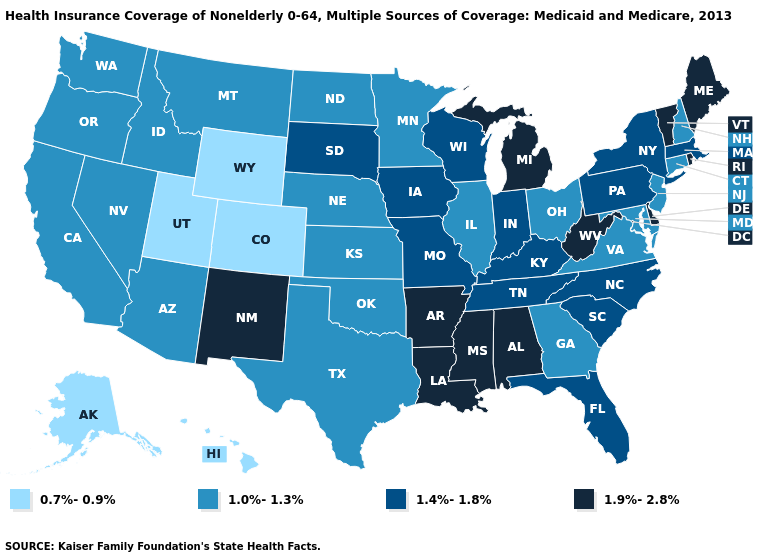Is the legend a continuous bar?
Quick response, please. No. Among the states that border New Hampshire , does Massachusetts have the highest value?
Short answer required. No. What is the lowest value in the Northeast?
Be succinct. 1.0%-1.3%. Name the states that have a value in the range 1.0%-1.3%?
Answer briefly. Arizona, California, Connecticut, Georgia, Idaho, Illinois, Kansas, Maryland, Minnesota, Montana, Nebraska, Nevada, New Hampshire, New Jersey, North Dakota, Ohio, Oklahoma, Oregon, Texas, Virginia, Washington. Among the states that border Wisconsin , does Michigan have the lowest value?
Write a very short answer. No. Among the states that border Minnesota , which have the highest value?
Concise answer only. Iowa, South Dakota, Wisconsin. Which states hav the highest value in the South?
Quick response, please. Alabama, Arkansas, Delaware, Louisiana, Mississippi, West Virginia. Among the states that border Idaho , does Utah have the lowest value?
Short answer required. Yes. Among the states that border Connecticut , which have the highest value?
Write a very short answer. Rhode Island. Does Rhode Island have the lowest value in the Northeast?
Write a very short answer. No. Is the legend a continuous bar?
Write a very short answer. No. Does New Hampshire have the lowest value in the USA?
Keep it brief. No. Does Delaware have a higher value than Iowa?
Give a very brief answer. Yes. Name the states that have a value in the range 1.0%-1.3%?
Keep it brief. Arizona, California, Connecticut, Georgia, Idaho, Illinois, Kansas, Maryland, Minnesota, Montana, Nebraska, Nevada, New Hampshire, New Jersey, North Dakota, Ohio, Oklahoma, Oregon, Texas, Virginia, Washington. What is the highest value in the USA?
Give a very brief answer. 1.9%-2.8%. 